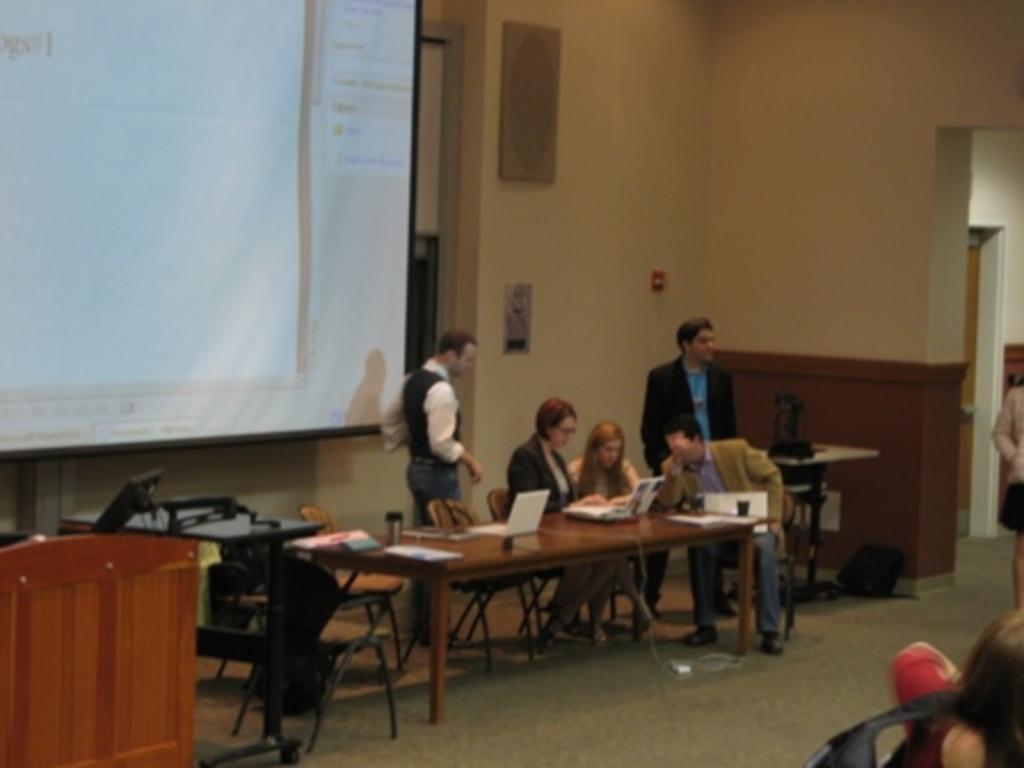Please provide a concise description of this image. In this image I see a few people and 3 of them are sitting on the chairs and 2 of them are standing and I can also see few people over here. In the background I see the wall and a screen. 